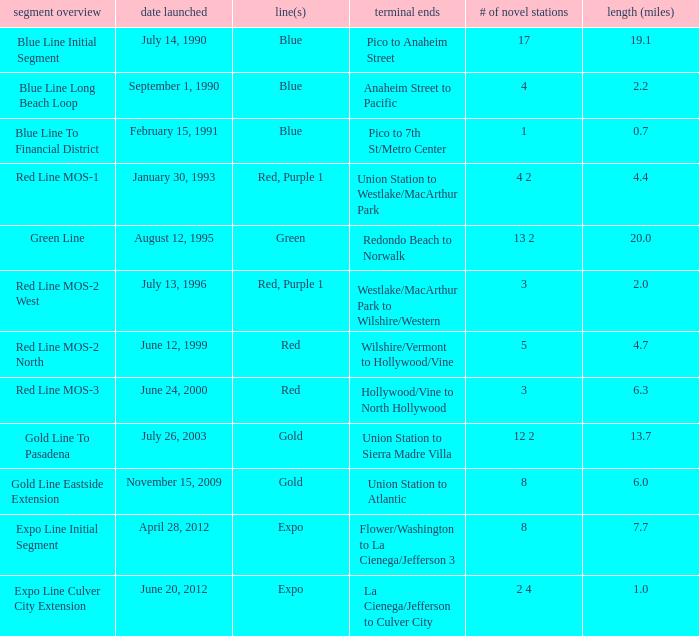How many news stations opened on the date of June 24, 2000? 3.0. I'm looking to parse the entire table for insights. Could you assist me with that? {'header': ['segment overview', 'date launched', 'line(s)', 'terminal ends', '# of novel stations', 'length (miles)'], 'rows': [['Blue Line Initial Segment', 'July 14, 1990', 'Blue', 'Pico to Anaheim Street', '17', '19.1'], ['Blue Line Long Beach Loop', 'September 1, 1990', 'Blue', 'Anaheim Street to Pacific', '4', '2.2'], ['Blue Line To Financial District', 'February 15, 1991', 'Blue', 'Pico to 7th St/Metro Center', '1', '0.7'], ['Red Line MOS-1', 'January 30, 1993', 'Red, Purple 1', 'Union Station to Westlake/MacArthur Park', '4 2', '4.4'], ['Green Line', 'August 12, 1995', 'Green', 'Redondo Beach to Norwalk', '13 2', '20.0'], ['Red Line MOS-2 West', 'July 13, 1996', 'Red, Purple 1', 'Westlake/MacArthur Park to Wilshire/Western', '3', '2.0'], ['Red Line MOS-2 North', 'June 12, 1999', 'Red', 'Wilshire/Vermont to Hollywood/Vine', '5', '4.7'], ['Red Line MOS-3', 'June 24, 2000', 'Red', 'Hollywood/Vine to North Hollywood', '3', '6.3'], ['Gold Line To Pasadena', 'July 26, 2003', 'Gold', 'Union Station to Sierra Madre Villa', '12 2', '13.7'], ['Gold Line Eastside Extension', 'November 15, 2009', 'Gold', 'Union Station to Atlantic', '8', '6.0'], ['Expo Line Initial Segment', 'April 28, 2012', 'Expo', 'Flower/Washington to La Cienega/Jefferson 3', '8', '7.7'], ['Expo Line Culver City Extension', 'June 20, 2012', 'Expo', 'La Cienega/Jefferson to Culver City', '2 4', '1.0']]} 